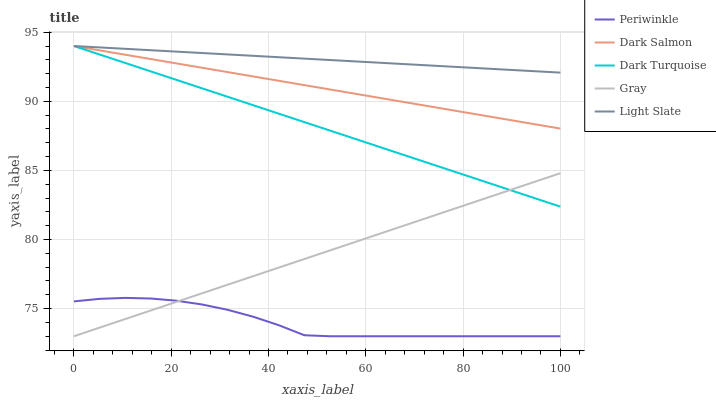Does Periwinkle have the minimum area under the curve?
Answer yes or no. Yes. Does Light Slate have the maximum area under the curve?
Answer yes or no. Yes. Does Dark Turquoise have the minimum area under the curve?
Answer yes or no. No. Does Dark Turquoise have the maximum area under the curve?
Answer yes or no. No. Is Gray the smoothest?
Answer yes or no. Yes. Is Periwinkle the roughest?
Answer yes or no. Yes. Is Dark Turquoise the smoothest?
Answer yes or no. No. Is Dark Turquoise the roughest?
Answer yes or no. No. Does Dark Turquoise have the lowest value?
Answer yes or no. No. Does Dark Salmon have the highest value?
Answer yes or no. Yes. Does Periwinkle have the highest value?
Answer yes or no. No. Is Periwinkle less than Light Slate?
Answer yes or no. Yes. Is Dark Turquoise greater than Periwinkle?
Answer yes or no. Yes. Does Periwinkle intersect Light Slate?
Answer yes or no. No. 